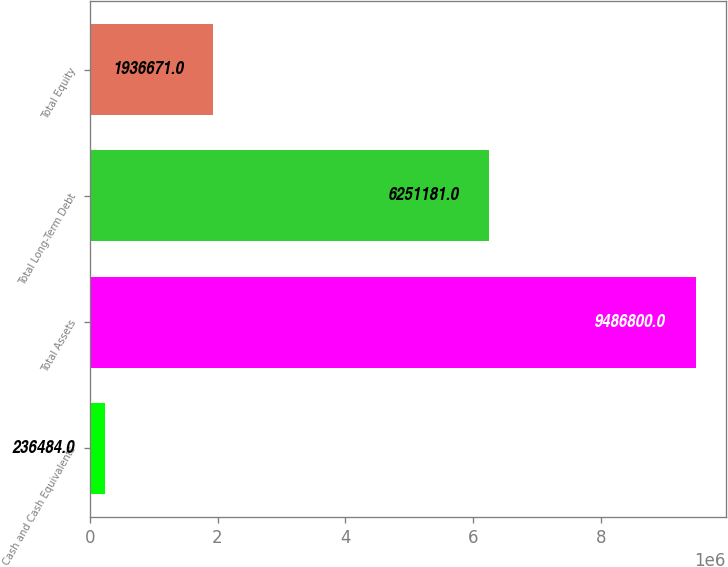Convert chart. <chart><loc_0><loc_0><loc_500><loc_500><bar_chart><fcel>Cash and Cash Equivalents<fcel>Total Assets<fcel>Total Long-Term Debt<fcel>Total Equity<nl><fcel>236484<fcel>9.4868e+06<fcel>6.25118e+06<fcel>1.93667e+06<nl></chart> 